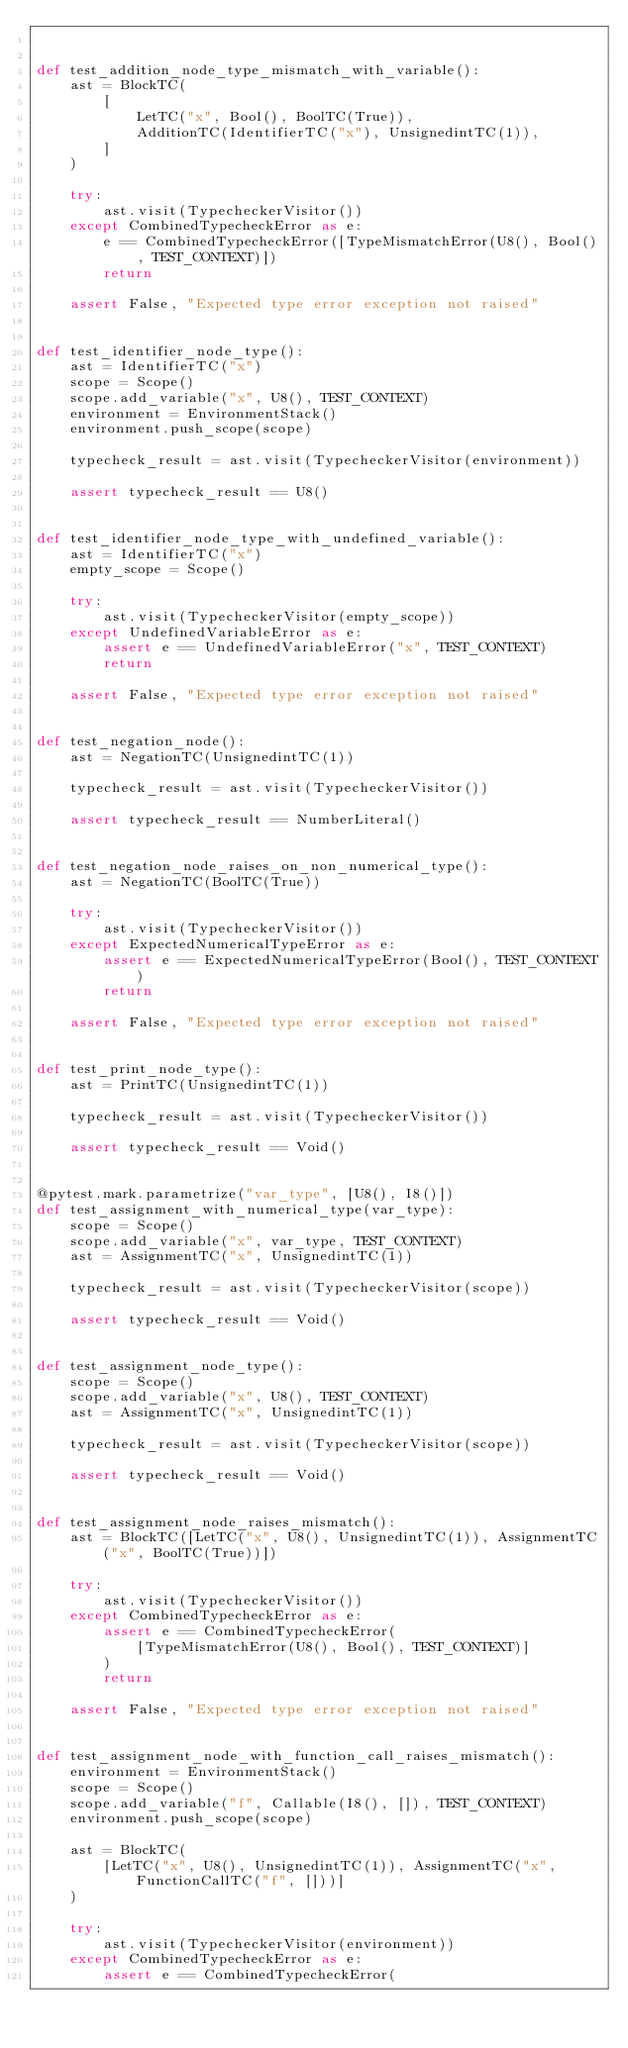<code> <loc_0><loc_0><loc_500><loc_500><_Python_>

def test_addition_node_type_mismatch_with_variable():
    ast = BlockTC(
        [
            LetTC("x", Bool(), BoolTC(True)),
            AdditionTC(IdentifierTC("x"), UnsignedintTC(1)),
        ]
    )

    try:
        ast.visit(TypecheckerVisitor())
    except CombinedTypecheckError as e:
        e == CombinedTypecheckError([TypeMismatchError(U8(), Bool(), TEST_CONTEXT)])
        return

    assert False, "Expected type error exception not raised"


def test_identifier_node_type():
    ast = IdentifierTC("x")
    scope = Scope()
    scope.add_variable("x", U8(), TEST_CONTEXT)
    environment = EnvironmentStack()
    environment.push_scope(scope)

    typecheck_result = ast.visit(TypecheckerVisitor(environment))

    assert typecheck_result == U8()


def test_identifier_node_type_with_undefined_variable():
    ast = IdentifierTC("x")
    empty_scope = Scope()

    try:
        ast.visit(TypecheckerVisitor(empty_scope))
    except UndefinedVariableError as e:
        assert e == UndefinedVariableError("x", TEST_CONTEXT)
        return

    assert False, "Expected type error exception not raised"


def test_negation_node():
    ast = NegationTC(UnsignedintTC(1))

    typecheck_result = ast.visit(TypecheckerVisitor())

    assert typecheck_result == NumberLiteral()


def test_negation_node_raises_on_non_numerical_type():
    ast = NegationTC(BoolTC(True))

    try:
        ast.visit(TypecheckerVisitor())
    except ExpectedNumericalTypeError as e:
        assert e == ExpectedNumericalTypeError(Bool(), TEST_CONTEXT)
        return

    assert False, "Expected type error exception not raised"


def test_print_node_type():
    ast = PrintTC(UnsignedintTC(1))

    typecheck_result = ast.visit(TypecheckerVisitor())

    assert typecheck_result == Void()


@pytest.mark.parametrize("var_type", [U8(), I8()])
def test_assignment_with_numerical_type(var_type):
    scope = Scope()
    scope.add_variable("x", var_type, TEST_CONTEXT)
    ast = AssignmentTC("x", UnsignedintTC(1))

    typecheck_result = ast.visit(TypecheckerVisitor(scope))

    assert typecheck_result == Void()


def test_assignment_node_type():
    scope = Scope()
    scope.add_variable("x", U8(), TEST_CONTEXT)
    ast = AssignmentTC("x", UnsignedintTC(1))

    typecheck_result = ast.visit(TypecheckerVisitor(scope))

    assert typecheck_result == Void()


def test_assignment_node_raises_mismatch():
    ast = BlockTC([LetTC("x", U8(), UnsignedintTC(1)), AssignmentTC("x", BoolTC(True))])

    try:
        ast.visit(TypecheckerVisitor())
    except CombinedTypecheckError as e:
        assert e == CombinedTypecheckError(
            [TypeMismatchError(U8(), Bool(), TEST_CONTEXT)]
        )
        return

    assert False, "Expected type error exception not raised"


def test_assignment_node_with_function_call_raises_mismatch():
    environment = EnvironmentStack()
    scope = Scope()
    scope.add_variable("f", Callable(I8(), []), TEST_CONTEXT)
    environment.push_scope(scope)

    ast = BlockTC(
        [LetTC("x", U8(), UnsignedintTC(1)), AssignmentTC("x", FunctionCallTC("f", []))]
    )

    try:
        ast.visit(TypecheckerVisitor(environment))
    except CombinedTypecheckError as e:
        assert e == CombinedTypecheckError(</code> 